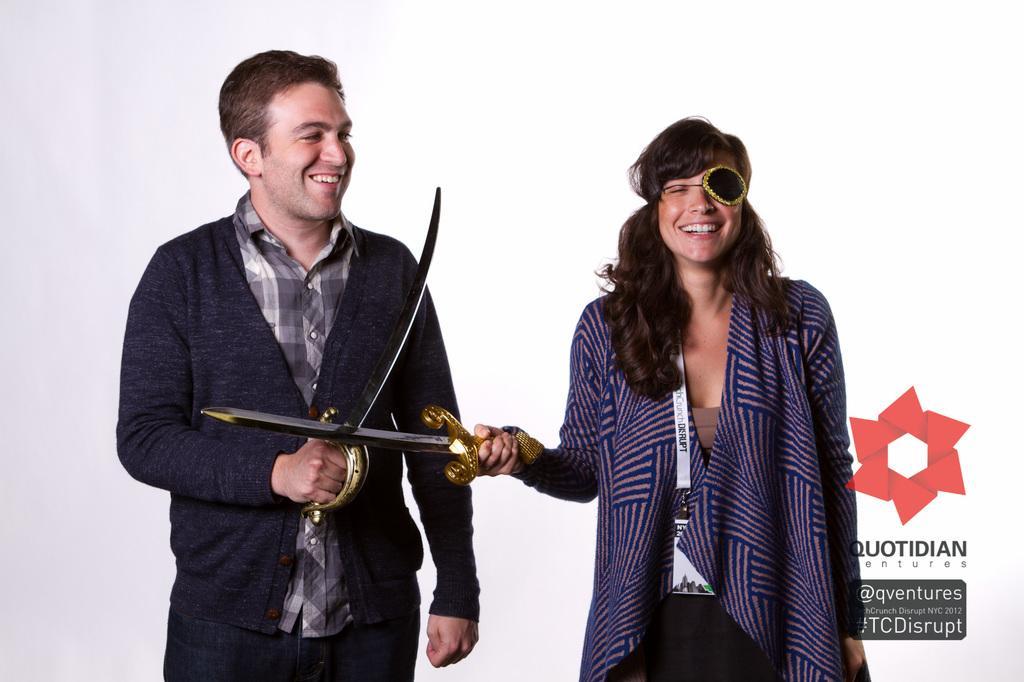Can you describe this image briefly? In this picture there are people standing and smiling and holding swords. In the bottom right side of the image we can see text and logo. 